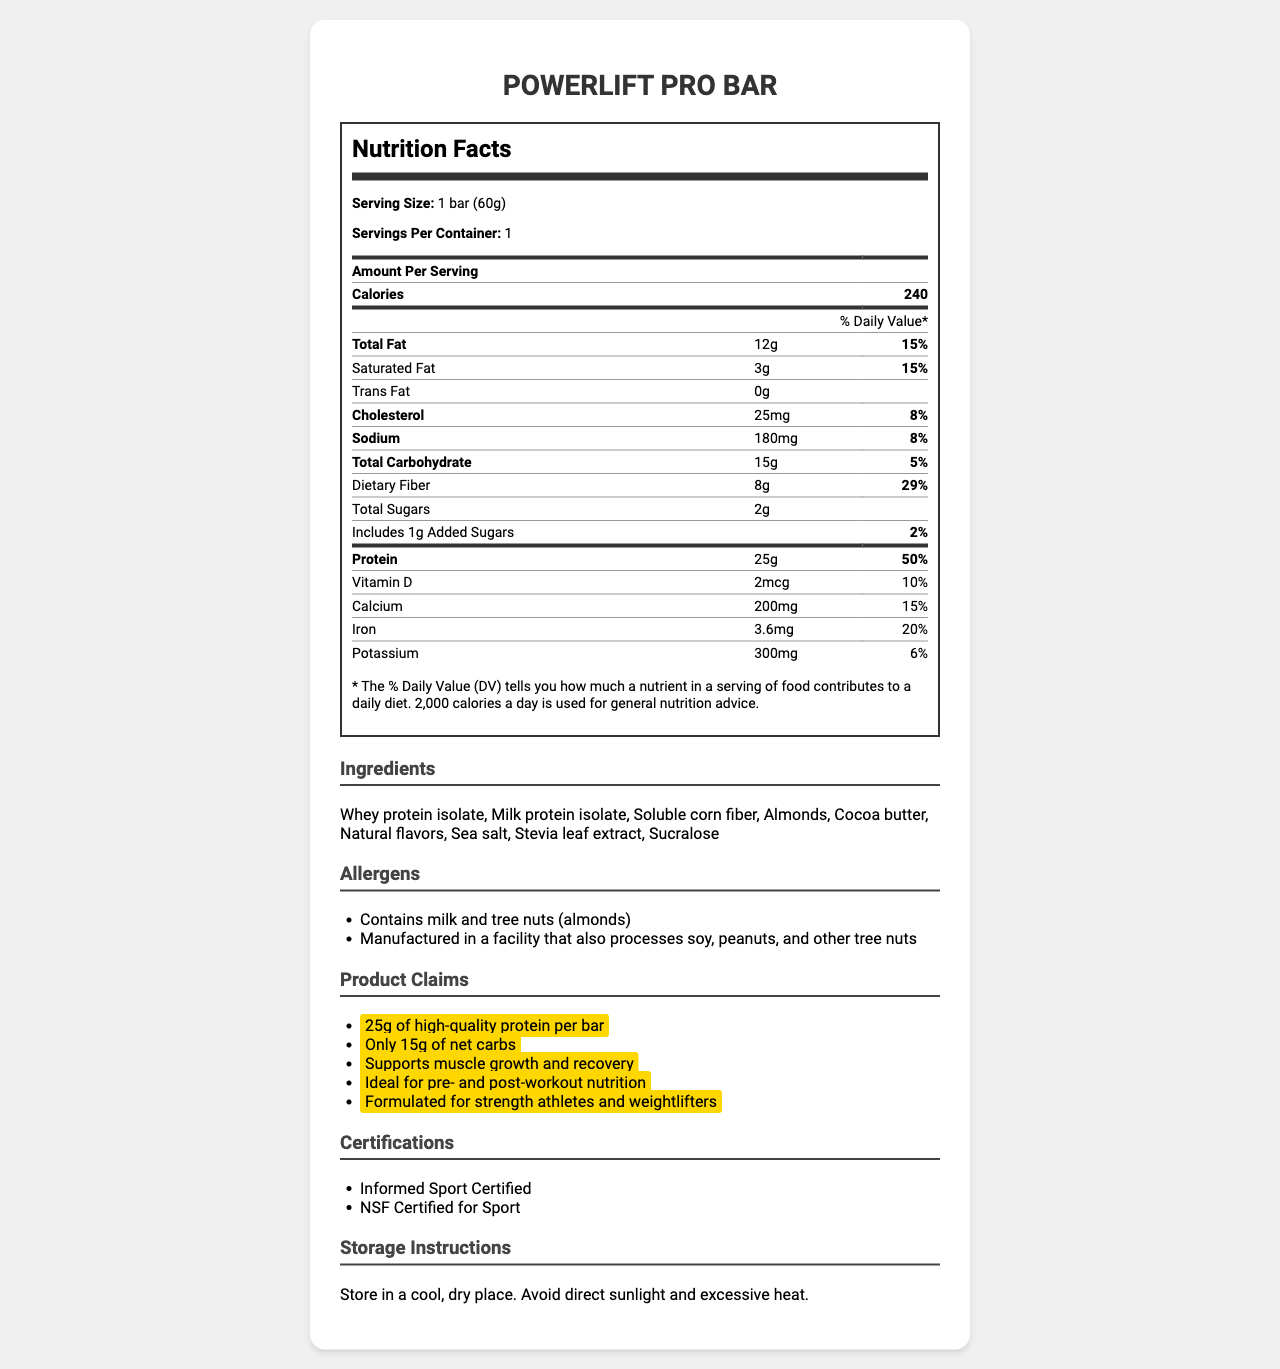what is the serving size of the PowerLift Pro Bar? The serving size information is clearly stated at the beginning of the nutrition facts table as "1 bar (60g)".
Answer: 1 bar (60g) how many grams of protein are in one serving of the PowerLift Pro Bar? The amount of protein per serving is specified under the nutrition facts as "Protein: 25g".
Answer: 25g what is the caloric content per serving of the PowerLift Pro Bar? The calories per serving is explicitly mentioned in the nutrition facts table as "Calories: 240".
Answer: 240 Calories how much dietary fiber is in each bar? The dietary fiber content is listed in the nutrition facts as "Dietary Fiber: 8g".
Answer: 8g what percentage of the daily value for total fat does one bar contribute? The percentage daily value for total fat is given in the nutrition facts as "Total Fat: 12g - 15%".
Answer: 15% what ingredients are included in the PowerLift Pro Bar? The ingredients are listed in the section labeled "Ingredients".
Answer: Whey protein isolate, Milk protein isolate, Soluble corn fiber, Almonds, Cocoa butter, Natural flavors, Sea salt, Stevia leaf extract, Sucralose how much added sugar does one bar contain? The amount of added sugar is listed in the nutrition facts as "Includes 1g Added Sugars: 2%".
Answer: 1g what is the amount of sodium in one serving? The sodium content per serving is specified in the nutrition facts as "Sodium: 180mg".
Answer: 180mg which allergens are present in the PowerLift Pro Bar? The allergens are mentioned in the section labeled "Allergens".
Answer: Contains milk and tree nuts (almonds) what certifications does the PowerLift Pro Bar have? The certifications are listed in the section labeled "Certifications".
Answer: Informed Sport Certified, NSF Certified for Sport what is the daily value percentage of calcium in one bar? The daily value percentage for calcium is provided in the nutrition facts as "Calcium: 200mg - 15%".
Answer: 15% what is the marketing claim related to muscle support? One of the marketing claims listed is "Supports muscle growth and recovery".
Answer: Supports muscle growth and recovery what is the storage instruction for the PowerLift Pro Bar? The storage instructions are listed in the section labeled "Storage Instructions".
Answer: Store in a cool, dry place. Avoid direct sunlight and excessive heat. does the PowerLift Pro Bar contain trans fat? The nutrition facts state "Trans Fat: 0g", indicating that there is no trans fat.
Answer: No what is the primary purpose of the PowerLift Pro Bar according to the marketing claims? One marketing claim states "Ideal for pre- and post-workout nutrition".
Answer: Ideal for pre- and post-workout nutrition is the PowerLift Pro Bar manufactured in a facility that processes soy? The allergen section includes "Manufactured in a facility that also processes soy", indicating the risk of cross-contamination.
Answer: Yes A. Total fat
B. Protein
C. Dietary fiber
D. Calcium The daily value percentages are listed as follows: Total fat 15%, Protein 50%, Dietary fiber 29%, Calcium 15%. Therefore, protein has the highest daily value percentage of 50%.
Answer: B. Protein A. 10g
B. 15g
C. 25g
D. 45g The nutrition facts list total carbohydrates as 15g, dietary fiber as 8g, and total sugars as 2g. Combining these amounts gives 15g + 8g + 2g = 25g.
Answer: C. 25g does the powerlift pro bar contain peanuts? The allergen section states it is manufactured in a facility that also processes peanuts, but it does not explicitly state that peanuts are in the bar itself.
Answer: Not enough information summarize the main idea of the document. The document outlines the composition and nutritional benefits of the PowerLift Pro Bar, focusing on high protein and low carbohydrate content, and providing insights into its suitability for athletes.
Answer: The document provides detailed nutrition information, ingredients, allergens, marketing claims, certifications, and storage instructions for the PowerLift Pro Bar, a high-protein, low-carb energy bar designed for strength athletes and weightlifters. 